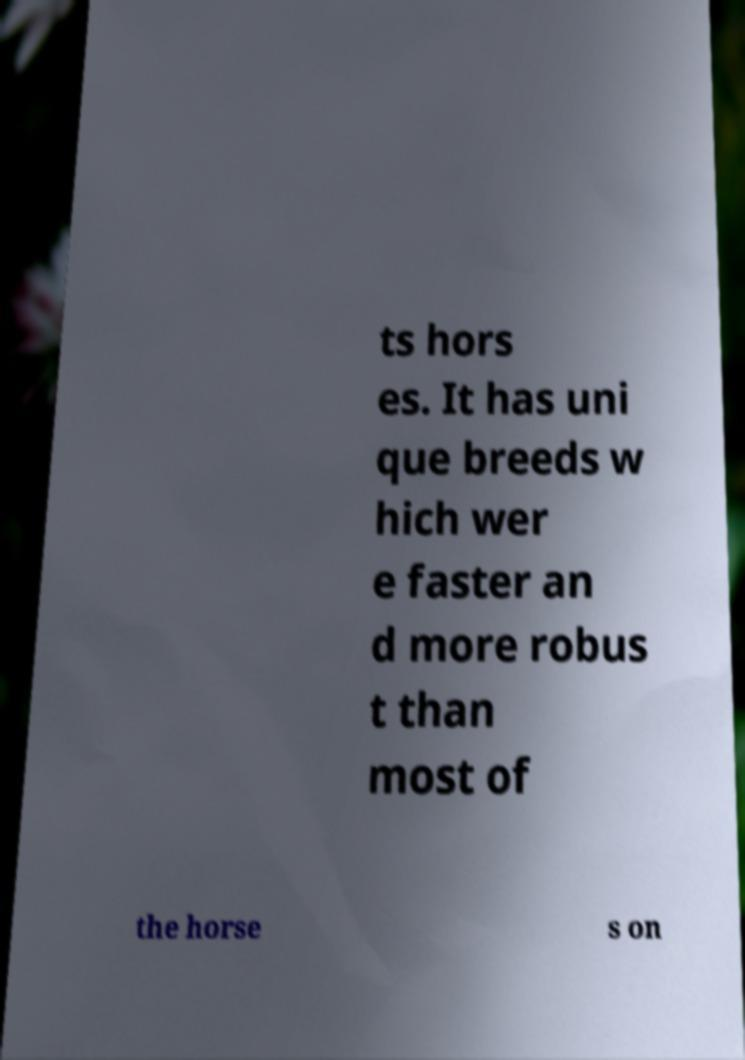I need the written content from this picture converted into text. Can you do that? ts hors es. It has uni que breeds w hich wer e faster an d more robus t than most of the horse s on 